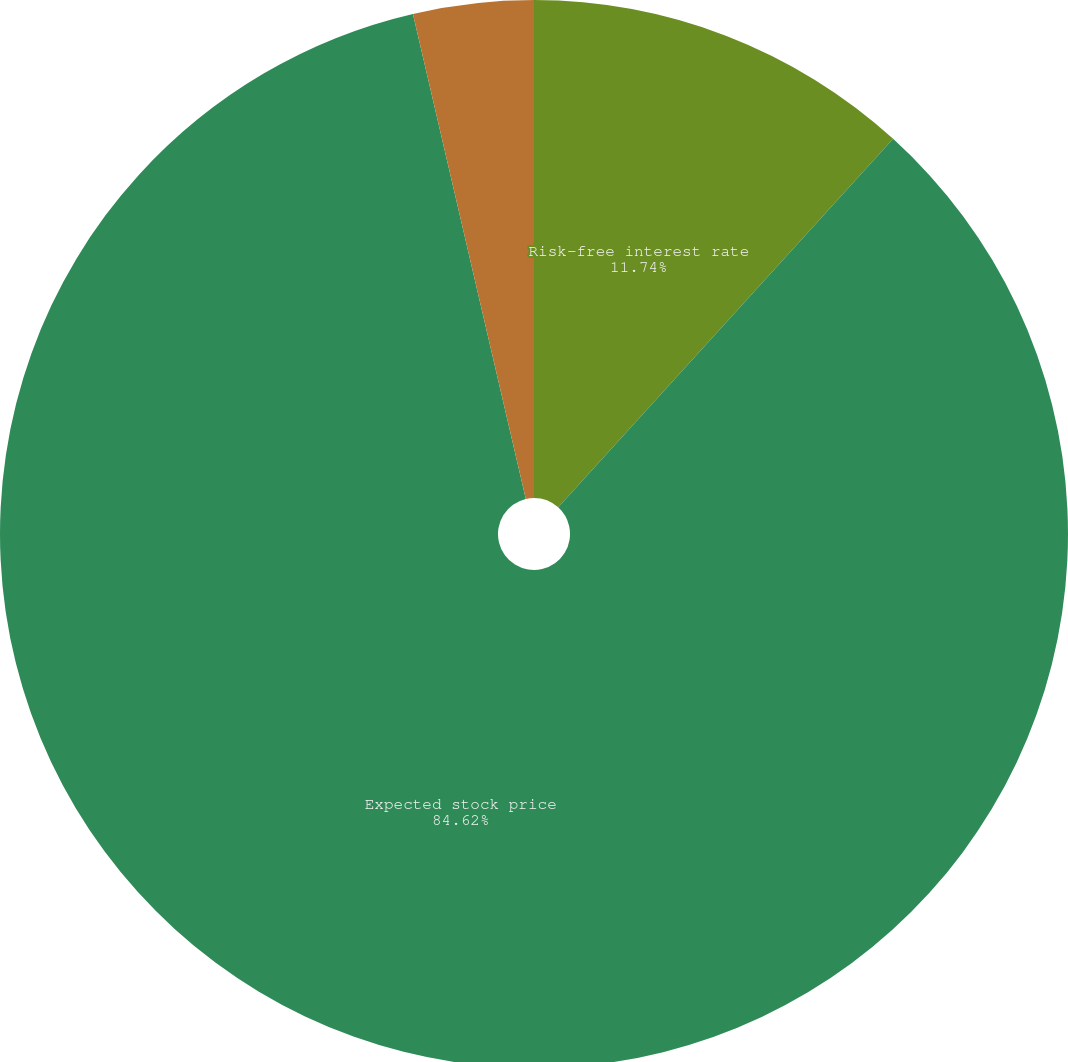<chart> <loc_0><loc_0><loc_500><loc_500><pie_chart><fcel>Risk-free interest rate<fcel>Expected stock price<fcel>Expected service period<nl><fcel>11.74%<fcel>84.63%<fcel>3.64%<nl></chart> 